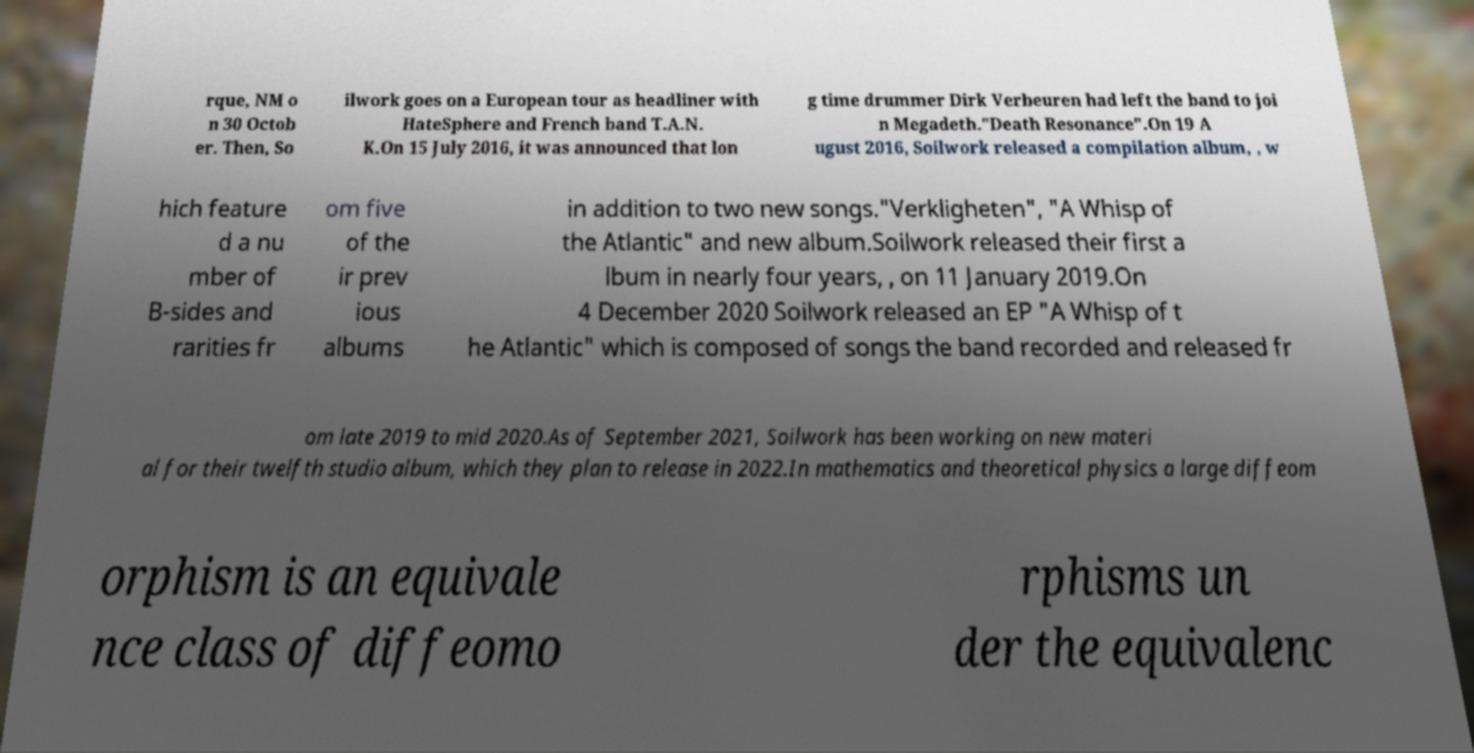Can you accurately transcribe the text from the provided image for me? rque, NM o n 30 Octob er. Then, So ilwork goes on a European tour as headliner with HateSphere and French band T.A.N. K.On 15 July 2016, it was announced that lon g time drummer Dirk Verbeuren had left the band to joi n Megadeth."Death Resonance".On 19 A ugust 2016, Soilwork released a compilation album, , w hich feature d a nu mber of B-sides and rarities fr om five of the ir prev ious albums in addition to two new songs."Verkligheten", "A Whisp of the Atlantic" and new album.Soilwork released their first a lbum in nearly four years, , on 11 January 2019.On 4 December 2020 Soilwork released an EP "A Whisp of t he Atlantic" which is composed of songs the band recorded and released fr om late 2019 to mid 2020.As of September 2021, Soilwork has been working on new materi al for their twelfth studio album, which they plan to release in 2022.In mathematics and theoretical physics a large diffeom orphism is an equivale nce class of diffeomo rphisms un der the equivalenc 